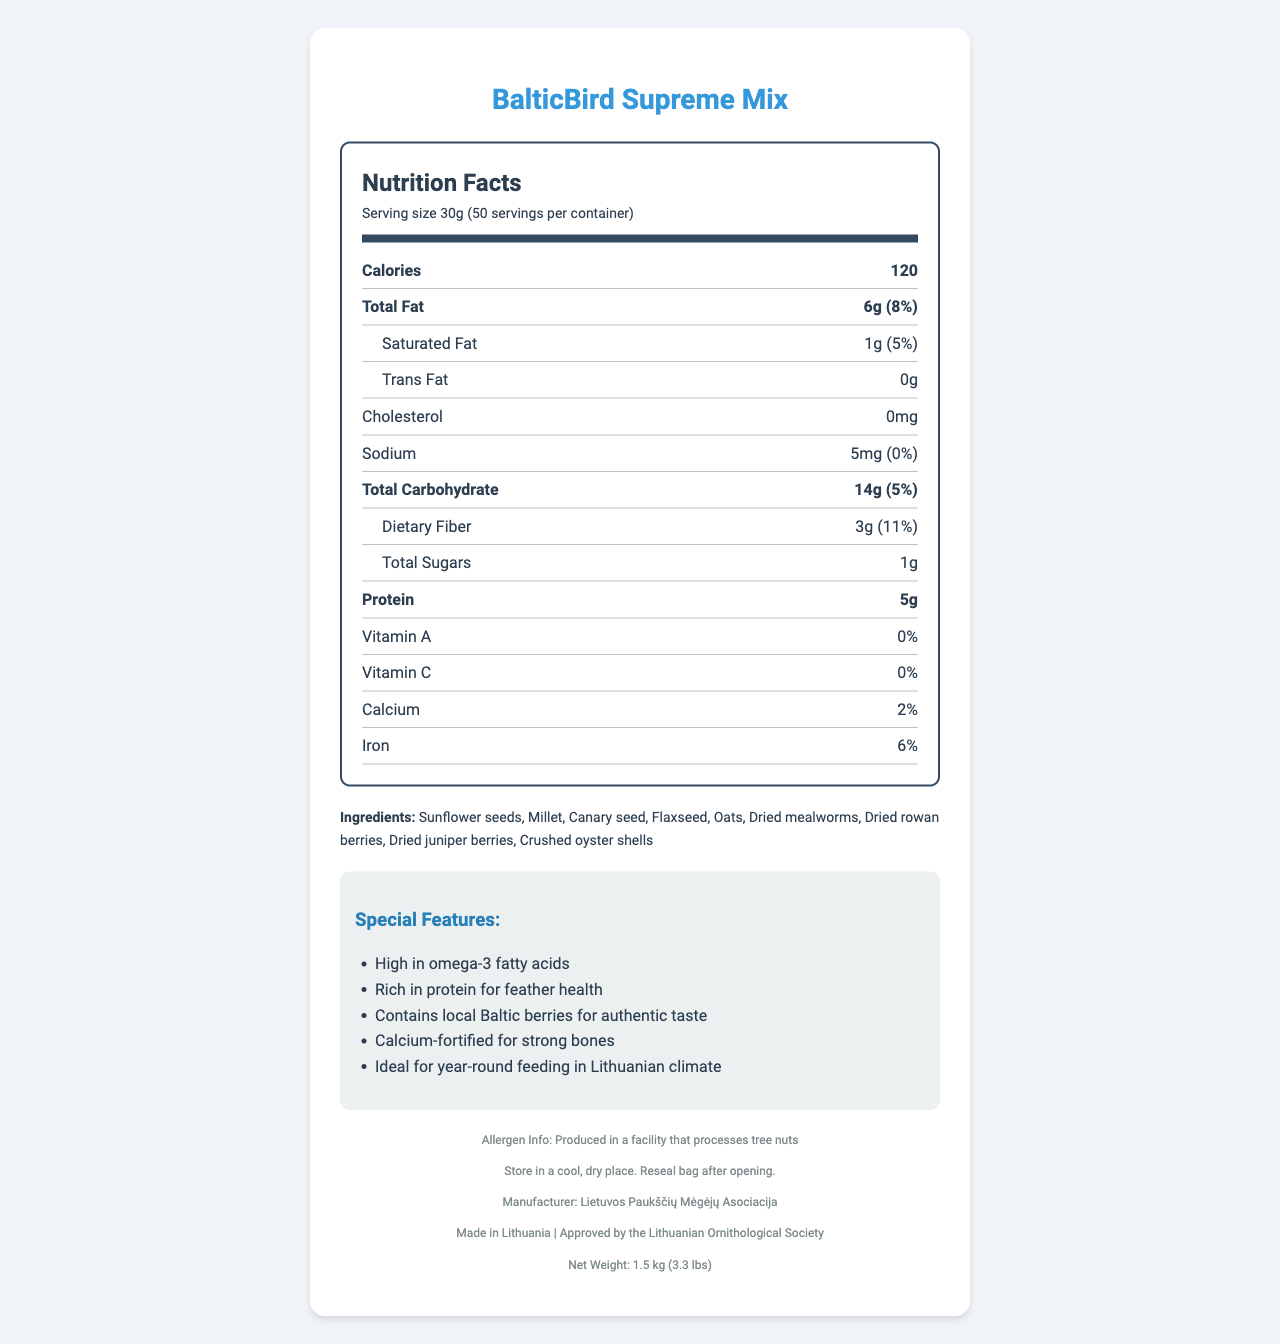what is the serving size of the BalticBird Supreme Mix? The serving size is listed under the Nutrition Facts section and states it is 30g.
Answer: 30g how many calories are there per serving? The document mentions that each serving contains 120 calories.
Answer: 120 name two types of seeds included in the ingredients The ingredients list includes sunflower seeds and millet among others.
Answer: Sunflower seeds, Millet how much protein is in one serving? The Nutrition Facts section shows that each serving has 5g of protein.
Answer: 5g what is the daily value percentage of iron? The daily value percentage of iron is listed as 6% in the Nutrition Facts.
Answer: 6% how many servings are in one container? The document states that there are 50 servings per container.
Answer: 50 which of the following birds is targeted by this seed mix?
A. House Sparrow
B. European Robin
C. Barn Swallow
D. Red-winged Blackbird The target species include European Robin and it is listed in the document.
Answer: B which nutrient has no daily value percentage listed?
I. Vitamin A
II. Cholesterol
III. Vitamin C
IV. Sodium Cholesterol is listed as "0mg" but has no associated daily value percentage.
Answer: II is this product suitable for year-round feeding in Lithuania? The special features section states that the product is ideal for year-round feeding in the Lithuanian climate.
Answer: Yes summarize the main special features of the BalticBird Supreme Mix The document lists the special features in detail.
Answer: High in omega-3 fatty acids, rich in protein for feather health, contains local Baltic berries for authentic taste, calcium-fortified for strong bones, ideal for year-round feeding in Lithuanian climate which nutrients are listed with their daily value percentage? These nutrients are shown in the Nutrition Facts section with their amounts and daily value percentages.
Answer: Total fat, saturated fat, sodium, total carbohydrate, dietary fiber, calcium, iron what is the storage instruction for this bird seed mix? This information is mentioned under the storage instructions section.
Answer: Store in a cool, dry place. Reseal bag after opening. what is the net weight of the product? The net weight is specified at the bottom of the document.
Answer: 1.5 kg (3.3 lbs) who manufactures the BalticBird Supreme Mix? The manufacturer is stated as Lietuvos Paukščių Mėgėjų Asociacija in the footer section.
Answer: Lietuvos Paukščių Mėgėjų Asociacija is the BalticBird Supreme Mix vitamin-fortified? The Nutrition Facts section shows 0% for both Vitamin A and Vitamin C, indicating it is not vitamin-fortified.
Answer: No what is the origin of the product? The footer section includes this information.
Answer: Made in Lithuania does this product contain any nuts? The allergen info mentions that it is produced in a facility that processes tree nuts but does not specify if the product itself contains tree nuts.
Answer: Cannot be determined 